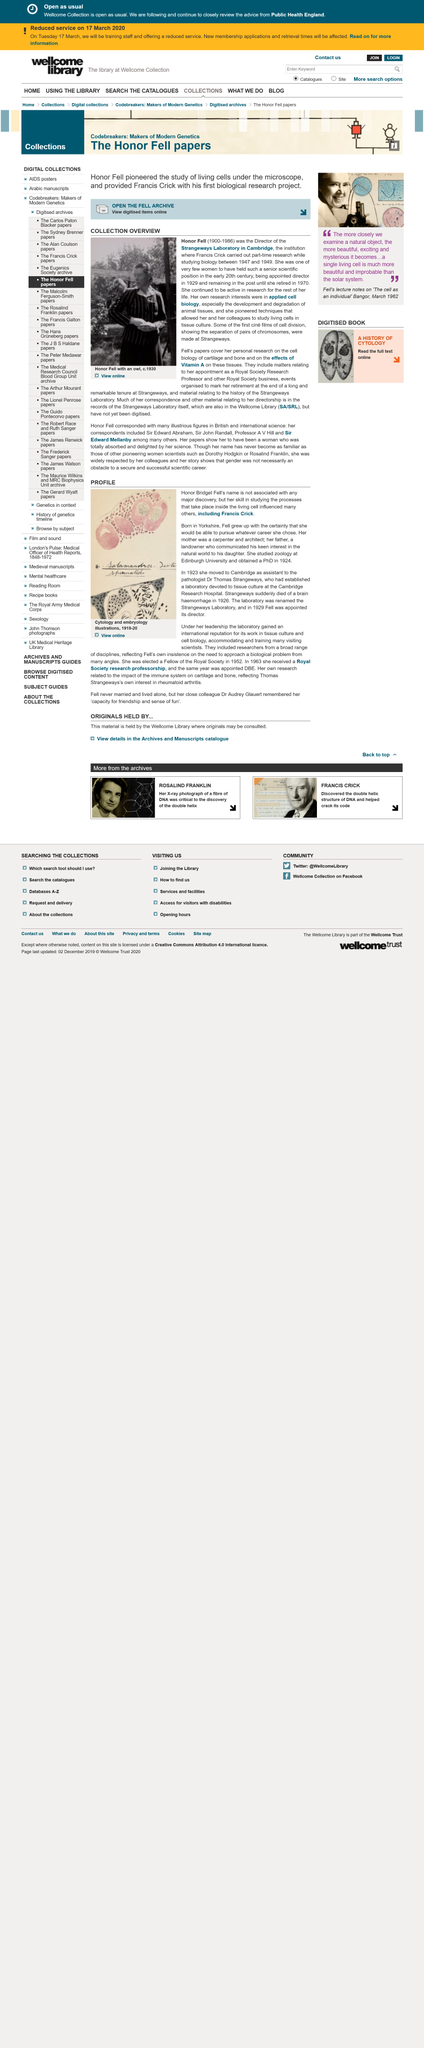Give some essential details in this illustration. Honor Fell passed away in 1986. Honor Fell was born in 1900. Honor Fell was a director of Strangeways Laboratory in Cambridge, and during her tenure, she was known for her exceptional leadership and management skills. 